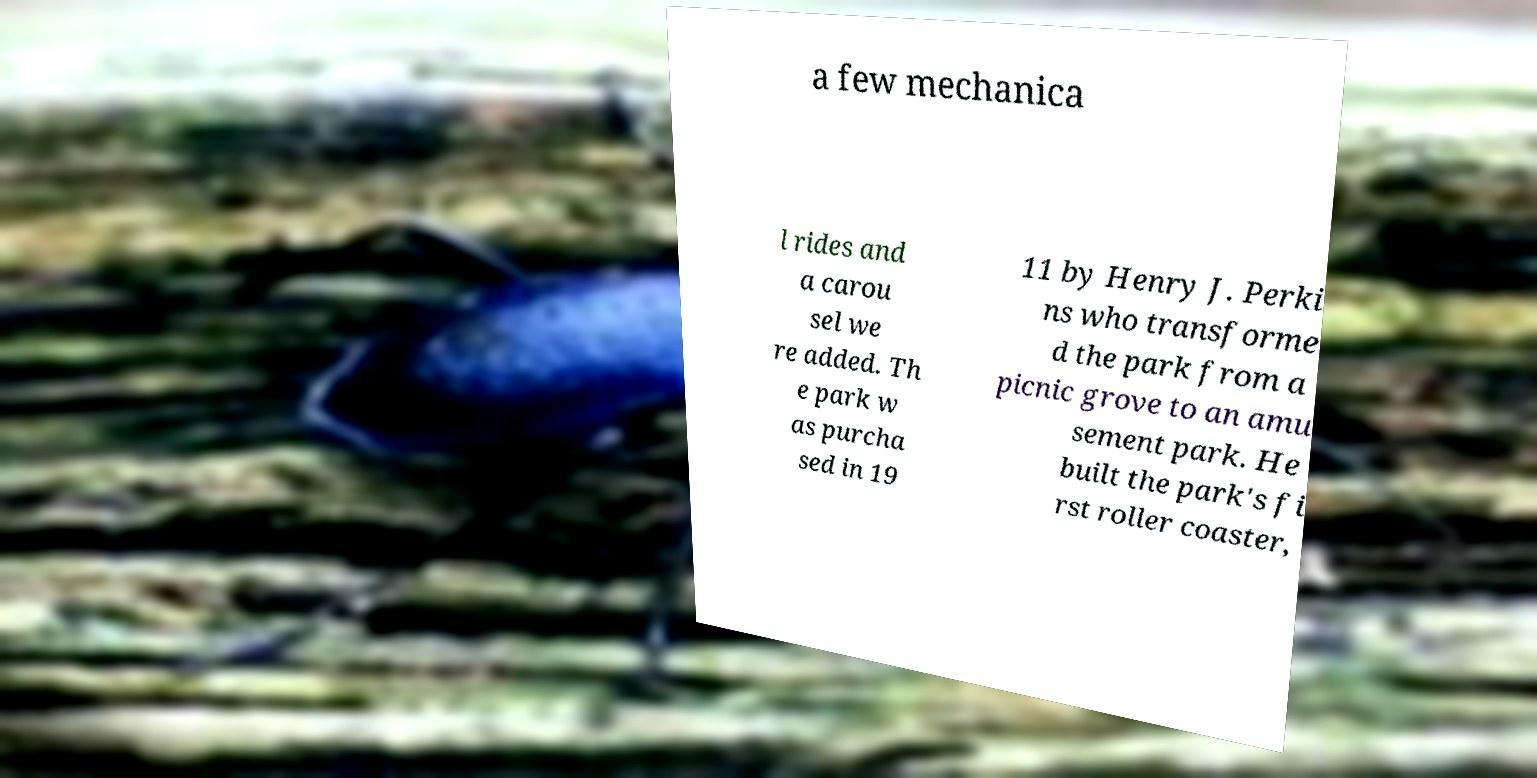I need the written content from this picture converted into text. Can you do that? a few mechanica l rides and a carou sel we re added. Th e park w as purcha sed in 19 11 by Henry J. Perki ns who transforme d the park from a picnic grove to an amu sement park. He built the park's fi rst roller coaster, 